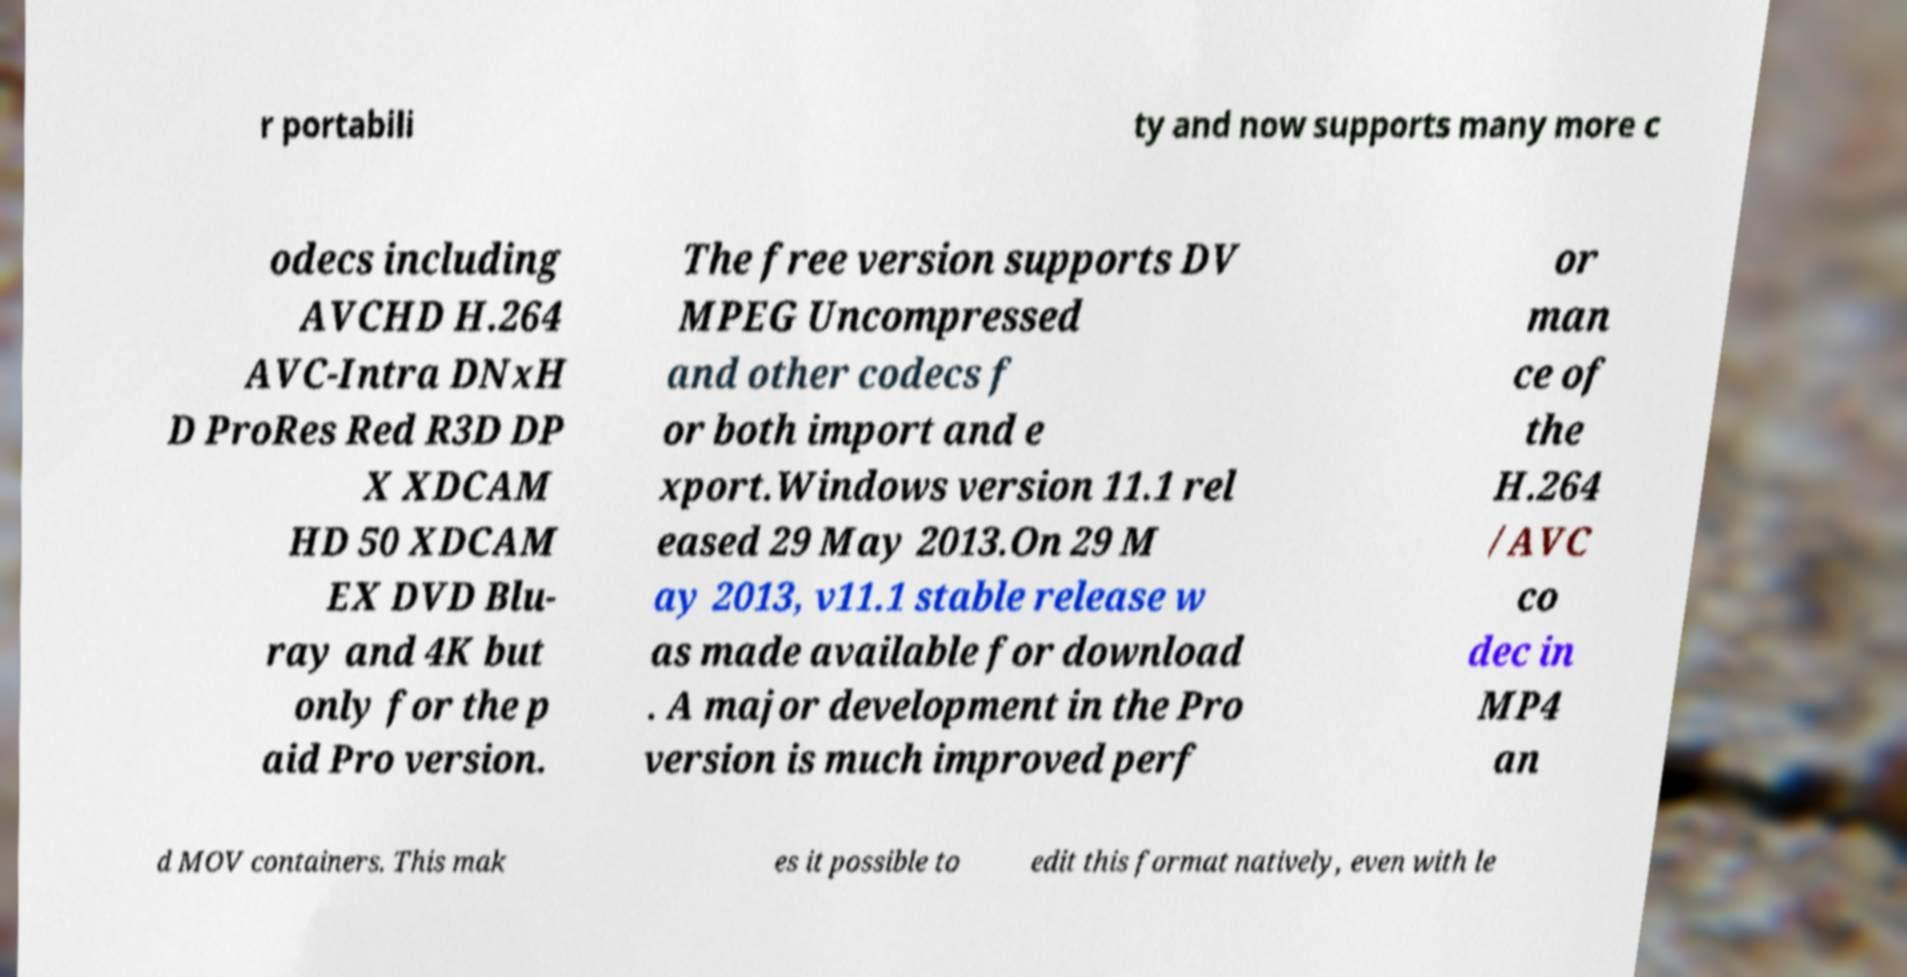Could you assist in decoding the text presented in this image and type it out clearly? r portabili ty and now supports many more c odecs including AVCHD H.264 AVC-Intra DNxH D ProRes Red R3D DP X XDCAM HD 50 XDCAM EX DVD Blu- ray and 4K but only for the p aid Pro version. The free version supports DV MPEG Uncompressed and other codecs f or both import and e xport.Windows version 11.1 rel eased 29 May 2013.On 29 M ay 2013, v11.1 stable release w as made available for download . A major development in the Pro version is much improved perf or man ce of the H.264 /AVC co dec in MP4 an d MOV containers. This mak es it possible to edit this format natively, even with le 